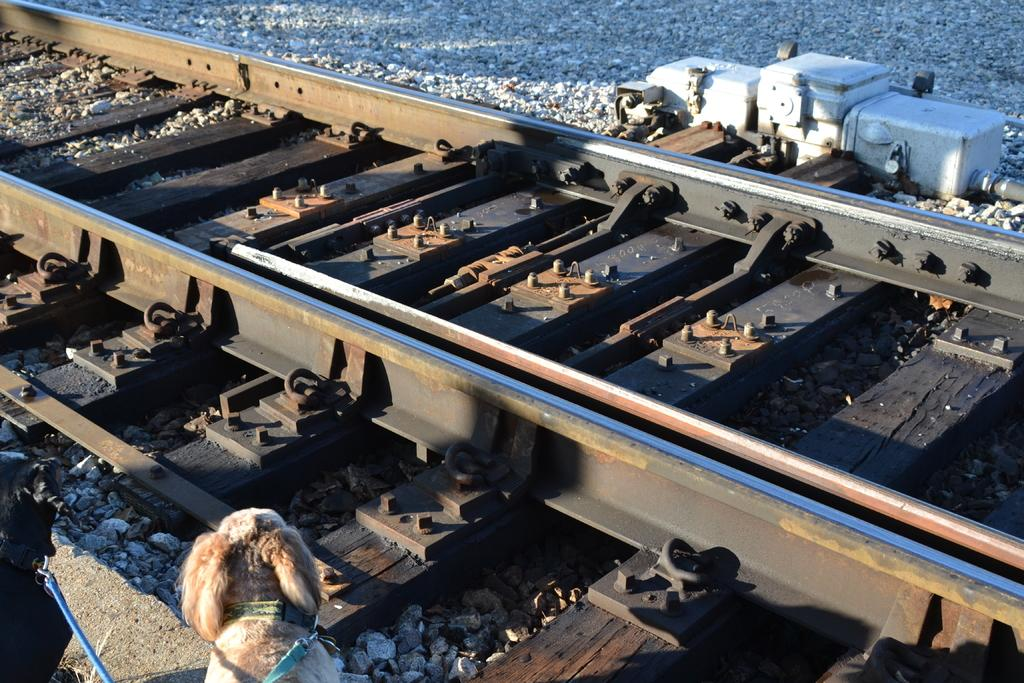What is the main feature of the image? There is a track in the image. What animals are near the track? There are dogs near the track. What colors are the dogs? The dogs are black and brown in color. What can be seen in the background of the image? There are many stones visible in the background of the image. What is the condition of the ball in the image? There is no ball present in the image. How does the downtown area look in the image? The image does not depict a downtown area; it features a track with dogs and a stony background. 